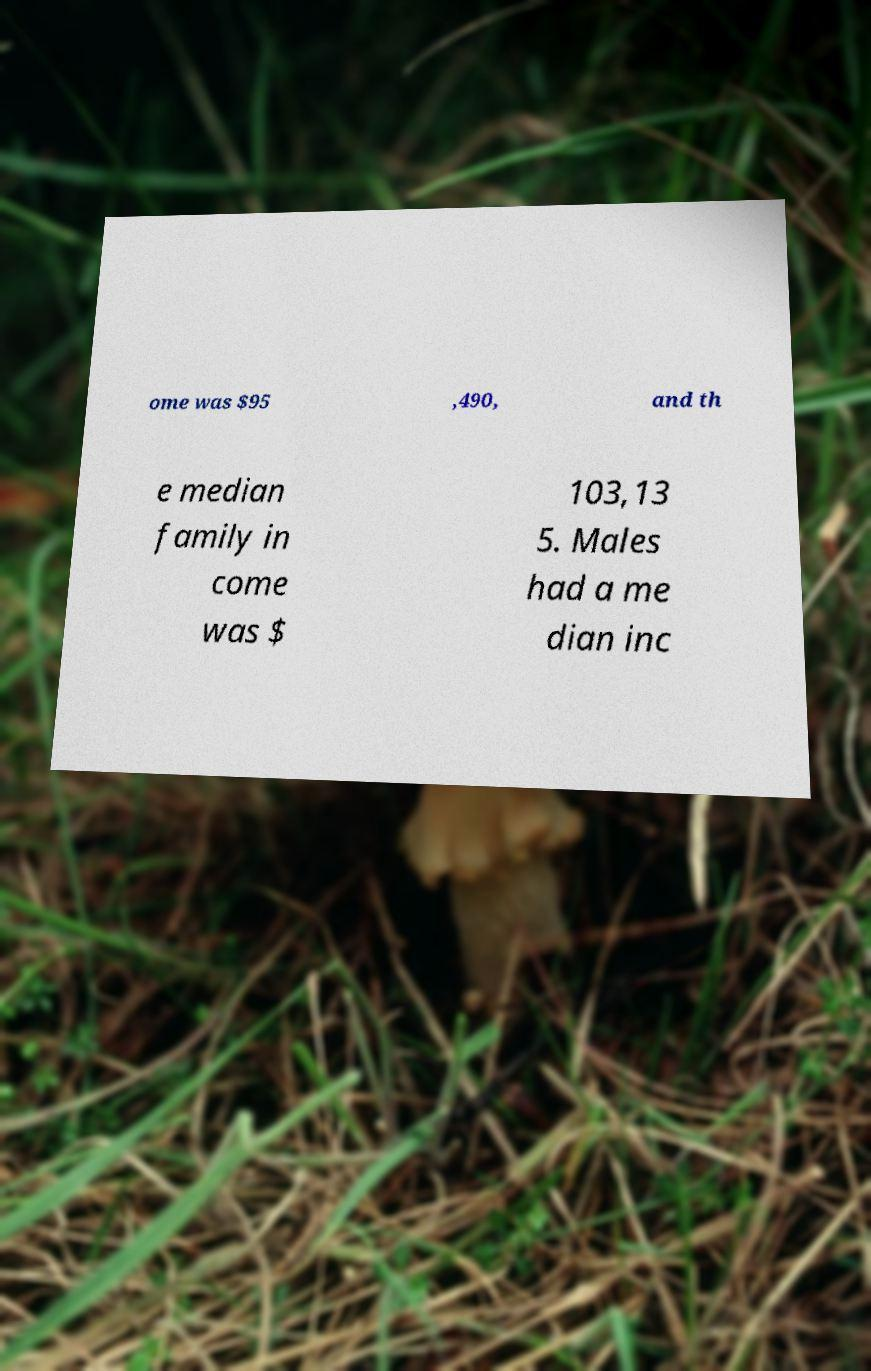For documentation purposes, I need the text within this image transcribed. Could you provide that? ome was $95 ,490, and th e median family in come was $ 103,13 5. Males had a me dian inc 